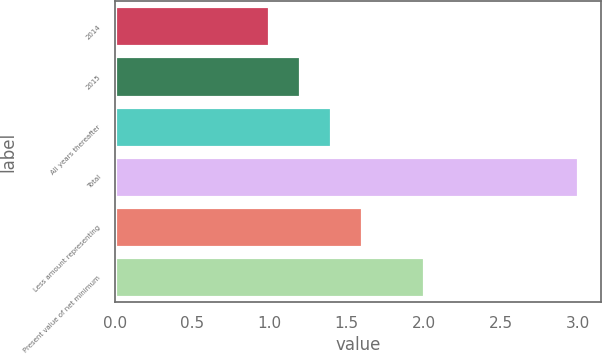Convert chart to OTSL. <chart><loc_0><loc_0><loc_500><loc_500><bar_chart><fcel>2014<fcel>2015<fcel>All years thereafter<fcel>Total<fcel>Less amount representing<fcel>Present value of net minimum<nl><fcel>1<fcel>1.2<fcel>1.4<fcel>3<fcel>1.6<fcel>2<nl></chart> 